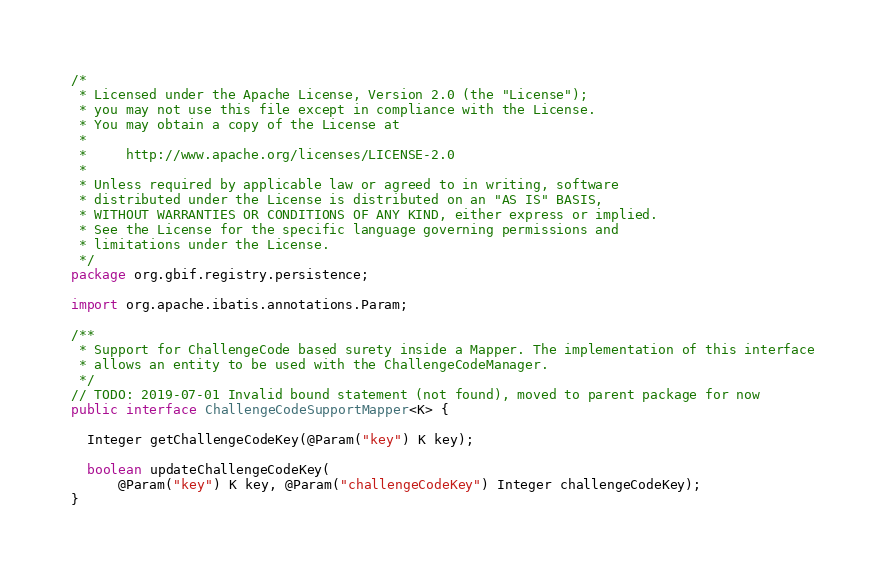Convert code to text. <code><loc_0><loc_0><loc_500><loc_500><_Java_>/*
 * Licensed under the Apache License, Version 2.0 (the "License");
 * you may not use this file except in compliance with the License.
 * You may obtain a copy of the License at
 *
 *     http://www.apache.org/licenses/LICENSE-2.0
 *
 * Unless required by applicable law or agreed to in writing, software
 * distributed under the License is distributed on an "AS IS" BASIS,
 * WITHOUT WARRANTIES OR CONDITIONS OF ANY KIND, either express or implied.
 * See the License for the specific language governing permissions and
 * limitations under the License.
 */
package org.gbif.registry.persistence;

import org.apache.ibatis.annotations.Param;

/**
 * Support for ChallengeCode based surety inside a Mapper. The implementation of this interface
 * allows an entity to be used with the ChallengeCodeManager.
 */
// TODO: 2019-07-01 Invalid bound statement (not found), moved to parent package for now
public interface ChallengeCodeSupportMapper<K> {

  Integer getChallengeCodeKey(@Param("key") K key);

  boolean updateChallengeCodeKey(
      @Param("key") K key, @Param("challengeCodeKey") Integer challengeCodeKey);
}
</code> 